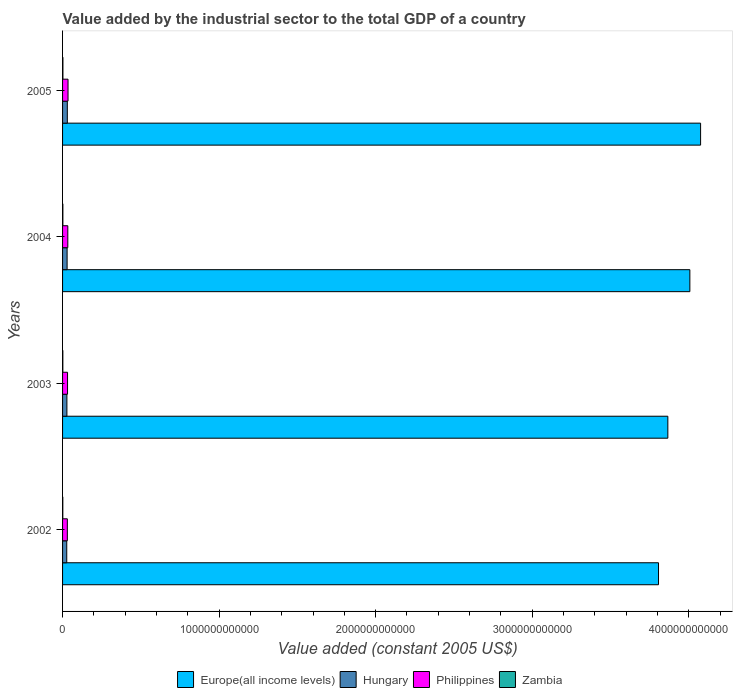How many different coloured bars are there?
Offer a very short reply. 4. Are the number of bars per tick equal to the number of legend labels?
Offer a terse response. Yes. How many bars are there on the 2nd tick from the top?
Offer a terse response. 4. How many bars are there on the 2nd tick from the bottom?
Provide a succinct answer. 4. What is the label of the 4th group of bars from the top?
Ensure brevity in your answer.  2002. In how many cases, is the number of bars for a given year not equal to the number of legend labels?
Ensure brevity in your answer.  0. What is the value added by the industrial sector in Europe(all income levels) in 2002?
Offer a very short reply. 3.81e+12. Across all years, what is the maximum value added by the industrial sector in Europe(all income levels)?
Provide a short and direct response. 4.08e+12. Across all years, what is the minimum value added by the industrial sector in Europe(all income levels)?
Provide a short and direct response. 3.81e+12. What is the total value added by the industrial sector in Zambia in the graph?
Your response must be concise. 7.59e+09. What is the difference between the value added by the industrial sector in Zambia in 2004 and that in 2005?
Offer a terse response. -2.41e+08. What is the difference between the value added by the industrial sector in Europe(all income levels) in 2003 and the value added by the industrial sector in Zambia in 2002?
Make the answer very short. 3.86e+12. What is the average value added by the industrial sector in Europe(all income levels) per year?
Offer a terse response. 3.94e+12. In the year 2005, what is the difference between the value added by the industrial sector in Philippines and value added by the industrial sector in Hungary?
Offer a terse response. 4.41e+09. In how many years, is the value added by the industrial sector in Zambia greater than 3400000000000 US$?
Provide a succinct answer. 0. What is the ratio of the value added by the industrial sector in Hungary in 2002 to that in 2003?
Ensure brevity in your answer.  0.96. Is the difference between the value added by the industrial sector in Philippines in 2002 and 2004 greater than the difference between the value added by the industrial sector in Hungary in 2002 and 2004?
Give a very brief answer. No. What is the difference between the highest and the second highest value added by the industrial sector in Philippines?
Your answer should be compact. 1.40e+09. What is the difference between the highest and the lowest value added by the industrial sector in Philippines?
Provide a short and direct response. 4.37e+09. What does the 3rd bar from the bottom in 2003 represents?
Provide a succinct answer. Philippines. How many bars are there?
Keep it short and to the point. 16. Are all the bars in the graph horizontal?
Your answer should be very brief. Yes. What is the difference between two consecutive major ticks on the X-axis?
Give a very brief answer. 1.00e+12. Are the values on the major ticks of X-axis written in scientific E-notation?
Your response must be concise. No. Does the graph contain any zero values?
Give a very brief answer. No. How many legend labels are there?
Give a very brief answer. 4. How are the legend labels stacked?
Offer a very short reply. Horizontal. What is the title of the graph?
Your response must be concise. Value added by the industrial sector to the total GDP of a country. What is the label or title of the X-axis?
Offer a very short reply. Value added (constant 2005 US$). What is the label or title of the Y-axis?
Provide a succinct answer. Years. What is the Value added (constant 2005 US$) in Europe(all income levels) in 2002?
Provide a short and direct response. 3.81e+12. What is the Value added (constant 2005 US$) in Hungary in 2002?
Your response must be concise. 2.67e+1. What is the Value added (constant 2005 US$) of Philippines in 2002?
Keep it short and to the point. 3.05e+1. What is the Value added (constant 2005 US$) in Zambia in 2002?
Offer a terse response. 1.59e+09. What is the Value added (constant 2005 US$) of Europe(all income levels) in 2003?
Ensure brevity in your answer.  3.87e+12. What is the Value added (constant 2005 US$) in Hungary in 2003?
Provide a succinct answer. 2.77e+1. What is the Value added (constant 2005 US$) of Philippines in 2003?
Keep it short and to the point. 3.18e+1. What is the Value added (constant 2005 US$) of Zambia in 2003?
Offer a terse response. 1.77e+09. What is the Value added (constant 2005 US$) in Europe(all income levels) in 2004?
Make the answer very short. 4.01e+12. What is the Value added (constant 2005 US$) of Hungary in 2004?
Provide a succinct answer. 2.90e+1. What is the Value added (constant 2005 US$) of Philippines in 2004?
Your response must be concise. 3.35e+1. What is the Value added (constant 2005 US$) of Zambia in 2004?
Make the answer very short. 2.00e+09. What is the Value added (constant 2005 US$) of Europe(all income levels) in 2005?
Your answer should be compact. 4.08e+12. What is the Value added (constant 2005 US$) in Hungary in 2005?
Ensure brevity in your answer.  3.05e+1. What is the Value added (constant 2005 US$) of Philippines in 2005?
Give a very brief answer. 3.49e+1. What is the Value added (constant 2005 US$) of Zambia in 2005?
Provide a short and direct response. 2.24e+09. Across all years, what is the maximum Value added (constant 2005 US$) in Europe(all income levels)?
Give a very brief answer. 4.08e+12. Across all years, what is the maximum Value added (constant 2005 US$) of Hungary?
Your answer should be compact. 3.05e+1. Across all years, what is the maximum Value added (constant 2005 US$) in Philippines?
Your response must be concise. 3.49e+1. Across all years, what is the maximum Value added (constant 2005 US$) in Zambia?
Your answer should be compact. 2.24e+09. Across all years, what is the minimum Value added (constant 2005 US$) of Europe(all income levels)?
Offer a very short reply. 3.81e+12. Across all years, what is the minimum Value added (constant 2005 US$) of Hungary?
Provide a short and direct response. 2.67e+1. Across all years, what is the minimum Value added (constant 2005 US$) in Philippines?
Give a very brief answer. 3.05e+1. Across all years, what is the minimum Value added (constant 2005 US$) of Zambia?
Offer a terse response. 1.59e+09. What is the total Value added (constant 2005 US$) of Europe(all income levels) in the graph?
Your answer should be compact. 1.58e+13. What is the total Value added (constant 2005 US$) of Hungary in the graph?
Your answer should be very brief. 1.14e+11. What is the total Value added (constant 2005 US$) in Philippines in the graph?
Offer a very short reply. 1.31e+11. What is the total Value added (constant 2005 US$) of Zambia in the graph?
Give a very brief answer. 7.59e+09. What is the difference between the Value added (constant 2005 US$) of Europe(all income levels) in 2002 and that in 2003?
Give a very brief answer. -5.97e+1. What is the difference between the Value added (constant 2005 US$) of Hungary in 2002 and that in 2003?
Ensure brevity in your answer.  -1.04e+09. What is the difference between the Value added (constant 2005 US$) in Philippines in 2002 and that in 2003?
Offer a very short reply. -1.30e+09. What is the difference between the Value added (constant 2005 US$) of Zambia in 2002 and that in 2003?
Your answer should be very brief. -1.83e+08. What is the difference between the Value added (constant 2005 US$) in Europe(all income levels) in 2002 and that in 2004?
Provide a succinct answer. -2.00e+11. What is the difference between the Value added (constant 2005 US$) of Hungary in 2002 and that in 2004?
Provide a short and direct response. -2.31e+09. What is the difference between the Value added (constant 2005 US$) in Philippines in 2002 and that in 2004?
Offer a terse response. -2.97e+09. What is the difference between the Value added (constant 2005 US$) in Zambia in 2002 and that in 2004?
Your answer should be very brief. -4.07e+08. What is the difference between the Value added (constant 2005 US$) in Europe(all income levels) in 2002 and that in 2005?
Offer a very short reply. -2.69e+11. What is the difference between the Value added (constant 2005 US$) of Hungary in 2002 and that in 2005?
Provide a succinct answer. -3.78e+09. What is the difference between the Value added (constant 2005 US$) of Philippines in 2002 and that in 2005?
Your answer should be compact. -4.37e+09. What is the difference between the Value added (constant 2005 US$) of Zambia in 2002 and that in 2005?
Make the answer very short. -6.48e+08. What is the difference between the Value added (constant 2005 US$) in Europe(all income levels) in 2003 and that in 2004?
Provide a short and direct response. -1.41e+11. What is the difference between the Value added (constant 2005 US$) in Hungary in 2003 and that in 2004?
Provide a short and direct response. -1.28e+09. What is the difference between the Value added (constant 2005 US$) of Philippines in 2003 and that in 2004?
Give a very brief answer. -1.66e+09. What is the difference between the Value added (constant 2005 US$) in Zambia in 2003 and that in 2004?
Your response must be concise. -2.24e+08. What is the difference between the Value added (constant 2005 US$) in Europe(all income levels) in 2003 and that in 2005?
Ensure brevity in your answer.  -2.09e+11. What is the difference between the Value added (constant 2005 US$) of Hungary in 2003 and that in 2005?
Give a very brief answer. -2.74e+09. What is the difference between the Value added (constant 2005 US$) in Philippines in 2003 and that in 2005?
Give a very brief answer. -3.07e+09. What is the difference between the Value added (constant 2005 US$) in Zambia in 2003 and that in 2005?
Offer a terse response. -4.65e+08. What is the difference between the Value added (constant 2005 US$) of Europe(all income levels) in 2004 and that in 2005?
Your response must be concise. -6.85e+1. What is the difference between the Value added (constant 2005 US$) in Hungary in 2004 and that in 2005?
Provide a succinct answer. -1.46e+09. What is the difference between the Value added (constant 2005 US$) in Philippines in 2004 and that in 2005?
Offer a very short reply. -1.40e+09. What is the difference between the Value added (constant 2005 US$) in Zambia in 2004 and that in 2005?
Offer a terse response. -2.41e+08. What is the difference between the Value added (constant 2005 US$) of Europe(all income levels) in 2002 and the Value added (constant 2005 US$) of Hungary in 2003?
Make the answer very short. 3.78e+12. What is the difference between the Value added (constant 2005 US$) of Europe(all income levels) in 2002 and the Value added (constant 2005 US$) of Philippines in 2003?
Offer a very short reply. 3.77e+12. What is the difference between the Value added (constant 2005 US$) of Europe(all income levels) in 2002 and the Value added (constant 2005 US$) of Zambia in 2003?
Offer a very short reply. 3.80e+12. What is the difference between the Value added (constant 2005 US$) in Hungary in 2002 and the Value added (constant 2005 US$) in Philippines in 2003?
Your answer should be compact. -5.12e+09. What is the difference between the Value added (constant 2005 US$) in Hungary in 2002 and the Value added (constant 2005 US$) in Zambia in 2003?
Your response must be concise. 2.49e+1. What is the difference between the Value added (constant 2005 US$) of Philippines in 2002 and the Value added (constant 2005 US$) of Zambia in 2003?
Your response must be concise. 2.87e+1. What is the difference between the Value added (constant 2005 US$) in Europe(all income levels) in 2002 and the Value added (constant 2005 US$) in Hungary in 2004?
Give a very brief answer. 3.78e+12. What is the difference between the Value added (constant 2005 US$) in Europe(all income levels) in 2002 and the Value added (constant 2005 US$) in Philippines in 2004?
Give a very brief answer. 3.77e+12. What is the difference between the Value added (constant 2005 US$) in Europe(all income levels) in 2002 and the Value added (constant 2005 US$) in Zambia in 2004?
Your answer should be compact. 3.80e+12. What is the difference between the Value added (constant 2005 US$) of Hungary in 2002 and the Value added (constant 2005 US$) of Philippines in 2004?
Offer a very short reply. -6.78e+09. What is the difference between the Value added (constant 2005 US$) in Hungary in 2002 and the Value added (constant 2005 US$) in Zambia in 2004?
Your response must be concise. 2.47e+1. What is the difference between the Value added (constant 2005 US$) of Philippines in 2002 and the Value added (constant 2005 US$) of Zambia in 2004?
Your response must be concise. 2.85e+1. What is the difference between the Value added (constant 2005 US$) in Europe(all income levels) in 2002 and the Value added (constant 2005 US$) in Hungary in 2005?
Your response must be concise. 3.78e+12. What is the difference between the Value added (constant 2005 US$) in Europe(all income levels) in 2002 and the Value added (constant 2005 US$) in Philippines in 2005?
Offer a very short reply. 3.77e+12. What is the difference between the Value added (constant 2005 US$) in Europe(all income levels) in 2002 and the Value added (constant 2005 US$) in Zambia in 2005?
Keep it short and to the point. 3.80e+12. What is the difference between the Value added (constant 2005 US$) in Hungary in 2002 and the Value added (constant 2005 US$) in Philippines in 2005?
Give a very brief answer. -8.19e+09. What is the difference between the Value added (constant 2005 US$) in Hungary in 2002 and the Value added (constant 2005 US$) in Zambia in 2005?
Your answer should be very brief. 2.44e+1. What is the difference between the Value added (constant 2005 US$) in Philippines in 2002 and the Value added (constant 2005 US$) in Zambia in 2005?
Your response must be concise. 2.83e+1. What is the difference between the Value added (constant 2005 US$) in Europe(all income levels) in 2003 and the Value added (constant 2005 US$) in Hungary in 2004?
Make the answer very short. 3.84e+12. What is the difference between the Value added (constant 2005 US$) in Europe(all income levels) in 2003 and the Value added (constant 2005 US$) in Philippines in 2004?
Your answer should be very brief. 3.83e+12. What is the difference between the Value added (constant 2005 US$) in Europe(all income levels) in 2003 and the Value added (constant 2005 US$) in Zambia in 2004?
Offer a terse response. 3.86e+12. What is the difference between the Value added (constant 2005 US$) of Hungary in 2003 and the Value added (constant 2005 US$) of Philippines in 2004?
Offer a terse response. -5.75e+09. What is the difference between the Value added (constant 2005 US$) in Hungary in 2003 and the Value added (constant 2005 US$) in Zambia in 2004?
Your response must be concise. 2.57e+1. What is the difference between the Value added (constant 2005 US$) of Philippines in 2003 and the Value added (constant 2005 US$) of Zambia in 2004?
Give a very brief answer. 2.98e+1. What is the difference between the Value added (constant 2005 US$) in Europe(all income levels) in 2003 and the Value added (constant 2005 US$) in Hungary in 2005?
Give a very brief answer. 3.84e+12. What is the difference between the Value added (constant 2005 US$) of Europe(all income levels) in 2003 and the Value added (constant 2005 US$) of Philippines in 2005?
Provide a succinct answer. 3.83e+12. What is the difference between the Value added (constant 2005 US$) of Europe(all income levels) in 2003 and the Value added (constant 2005 US$) of Zambia in 2005?
Keep it short and to the point. 3.86e+12. What is the difference between the Value added (constant 2005 US$) in Hungary in 2003 and the Value added (constant 2005 US$) in Philippines in 2005?
Provide a short and direct response. -7.15e+09. What is the difference between the Value added (constant 2005 US$) of Hungary in 2003 and the Value added (constant 2005 US$) of Zambia in 2005?
Offer a terse response. 2.55e+1. What is the difference between the Value added (constant 2005 US$) in Philippines in 2003 and the Value added (constant 2005 US$) in Zambia in 2005?
Provide a short and direct response. 2.96e+1. What is the difference between the Value added (constant 2005 US$) of Europe(all income levels) in 2004 and the Value added (constant 2005 US$) of Hungary in 2005?
Your answer should be very brief. 3.98e+12. What is the difference between the Value added (constant 2005 US$) of Europe(all income levels) in 2004 and the Value added (constant 2005 US$) of Philippines in 2005?
Provide a short and direct response. 3.97e+12. What is the difference between the Value added (constant 2005 US$) of Europe(all income levels) in 2004 and the Value added (constant 2005 US$) of Zambia in 2005?
Your answer should be compact. 4.00e+12. What is the difference between the Value added (constant 2005 US$) in Hungary in 2004 and the Value added (constant 2005 US$) in Philippines in 2005?
Your answer should be very brief. -5.87e+09. What is the difference between the Value added (constant 2005 US$) of Hungary in 2004 and the Value added (constant 2005 US$) of Zambia in 2005?
Ensure brevity in your answer.  2.68e+1. What is the difference between the Value added (constant 2005 US$) of Philippines in 2004 and the Value added (constant 2005 US$) of Zambia in 2005?
Offer a very short reply. 3.12e+1. What is the average Value added (constant 2005 US$) in Europe(all income levels) per year?
Provide a succinct answer. 3.94e+12. What is the average Value added (constant 2005 US$) of Hungary per year?
Provide a short and direct response. 2.85e+1. What is the average Value added (constant 2005 US$) in Philippines per year?
Give a very brief answer. 3.27e+1. What is the average Value added (constant 2005 US$) in Zambia per year?
Offer a terse response. 1.90e+09. In the year 2002, what is the difference between the Value added (constant 2005 US$) in Europe(all income levels) and Value added (constant 2005 US$) in Hungary?
Your answer should be compact. 3.78e+12. In the year 2002, what is the difference between the Value added (constant 2005 US$) in Europe(all income levels) and Value added (constant 2005 US$) in Philippines?
Keep it short and to the point. 3.78e+12. In the year 2002, what is the difference between the Value added (constant 2005 US$) of Europe(all income levels) and Value added (constant 2005 US$) of Zambia?
Provide a short and direct response. 3.81e+12. In the year 2002, what is the difference between the Value added (constant 2005 US$) in Hungary and Value added (constant 2005 US$) in Philippines?
Your response must be concise. -3.82e+09. In the year 2002, what is the difference between the Value added (constant 2005 US$) in Hungary and Value added (constant 2005 US$) in Zambia?
Your response must be concise. 2.51e+1. In the year 2002, what is the difference between the Value added (constant 2005 US$) in Philippines and Value added (constant 2005 US$) in Zambia?
Provide a short and direct response. 2.89e+1. In the year 2003, what is the difference between the Value added (constant 2005 US$) of Europe(all income levels) and Value added (constant 2005 US$) of Hungary?
Keep it short and to the point. 3.84e+12. In the year 2003, what is the difference between the Value added (constant 2005 US$) of Europe(all income levels) and Value added (constant 2005 US$) of Philippines?
Make the answer very short. 3.83e+12. In the year 2003, what is the difference between the Value added (constant 2005 US$) in Europe(all income levels) and Value added (constant 2005 US$) in Zambia?
Offer a very short reply. 3.86e+12. In the year 2003, what is the difference between the Value added (constant 2005 US$) of Hungary and Value added (constant 2005 US$) of Philippines?
Keep it short and to the point. -4.08e+09. In the year 2003, what is the difference between the Value added (constant 2005 US$) of Hungary and Value added (constant 2005 US$) of Zambia?
Provide a succinct answer. 2.60e+1. In the year 2003, what is the difference between the Value added (constant 2005 US$) in Philippines and Value added (constant 2005 US$) in Zambia?
Offer a very short reply. 3.00e+1. In the year 2004, what is the difference between the Value added (constant 2005 US$) in Europe(all income levels) and Value added (constant 2005 US$) in Hungary?
Offer a terse response. 3.98e+12. In the year 2004, what is the difference between the Value added (constant 2005 US$) in Europe(all income levels) and Value added (constant 2005 US$) in Philippines?
Give a very brief answer. 3.97e+12. In the year 2004, what is the difference between the Value added (constant 2005 US$) in Europe(all income levels) and Value added (constant 2005 US$) in Zambia?
Your answer should be compact. 4.00e+12. In the year 2004, what is the difference between the Value added (constant 2005 US$) of Hungary and Value added (constant 2005 US$) of Philippines?
Your answer should be compact. -4.47e+09. In the year 2004, what is the difference between the Value added (constant 2005 US$) of Hungary and Value added (constant 2005 US$) of Zambia?
Provide a short and direct response. 2.70e+1. In the year 2004, what is the difference between the Value added (constant 2005 US$) of Philippines and Value added (constant 2005 US$) of Zambia?
Give a very brief answer. 3.15e+1. In the year 2005, what is the difference between the Value added (constant 2005 US$) in Europe(all income levels) and Value added (constant 2005 US$) in Hungary?
Provide a short and direct response. 4.04e+12. In the year 2005, what is the difference between the Value added (constant 2005 US$) in Europe(all income levels) and Value added (constant 2005 US$) in Philippines?
Make the answer very short. 4.04e+12. In the year 2005, what is the difference between the Value added (constant 2005 US$) of Europe(all income levels) and Value added (constant 2005 US$) of Zambia?
Offer a terse response. 4.07e+12. In the year 2005, what is the difference between the Value added (constant 2005 US$) of Hungary and Value added (constant 2005 US$) of Philippines?
Provide a short and direct response. -4.41e+09. In the year 2005, what is the difference between the Value added (constant 2005 US$) in Hungary and Value added (constant 2005 US$) in Zambia?
Make the answer very short. 2.82e+1. In the year 2005, what is the difference between the Value added (constant 2005 US$) in Philippines and Value added (constant 2005 US$) in Zambia?
Your answer should be very brief. 3.26e+1. What is the ratio of the Value added (constant 2005 US$) of Europe(all income levels) in 2002 to that in 2003?
Make the answer very short. 0.98. What is the ratio of the Value added (constant 2005 US$) of Hungary in 2002 to that in 2003?
Offer a terse response. 0.96. What is the ratio of the Value added (constant 2005 US$) of Zambia in 2002 to that in 2003?
Give a very brief answer. 0.9. What is the ratio of the Value added (constant 2005 US$) in Hungary in 2002 to that in 2004?
Provide a succinct answer. 0.92. What is the ratio of the Value added (constant 2005 US$) in Philippines in 2002 to that in 2004?
Offer a very short reply. 0.91. What is the ratio of the Value added (constant 2005 US$) of Zambia in 2002 to that in 2004?
Provide a succinct answer. 0.8. What is the ratio of the Value added (constant 2005 US$) in Europe(all income levels) in 2002 to that in 2005?
Give a very brief answer. 0.93. What is the ratio of the Value added (constant 2005 US$) in Hungary in 2002 to that in 2005?
Ensure brevity in your answer.  0.88. What is the ratio of the Value added (constant 2005 US$) of Philippines in 2002 to that in 2005?
Your answer should be compact. 0.87. What is the ratio of the Value added (constant 2005 US$) of Zambia in 2002 to that in 2005?
Offer a terse response. 0.71. What is the ratio of the Value added (constant 2005 US$) of Europe(all income levels) in 2003 to that in 2004?
Your answer should be very brief. 0.96. What is the ratio of the Value added (constant 2005 US$) in Hungary in 2003 to that in 2004?
Make the answer very short. 0.96. What is the ratio of the Value added (constant 2005 US$) in Philippines in 2003 to that in 2004?
Keep it short and to the point. 0.95. What is the ratio of the Value added (constant 2005 US$) of Zambia in 2003 to that in 2004?
Your answer should be very brief. 0.89. What is the ratio of the Value added (constant 2005 US$) of Europe(all income levels) in 2003 to that in 2005?
Your answer should be very brief. 0.95. What is the ratio of the Value added (constant 2005 US$) of Hungary in 2003 to that in 2005?
Offer a very short reply. 0.91. What is the ratio of the Value added (constant 2005 US$) of Philippines in 2003 to that in 2005?
Your answer should be compact. 0.91. What is the ratio of the Value added (constant 2005 US$) of Zambia in 2003 to that in 2005?
Offer a terse response. 0.79. What is the ratio of the Value added (constant 2005 US$) of Europe(all income levels) in 2004 to that in 2005?
Your answer should be compact. 0.98. What is the ratio of the Value added (constant 2005 US$) in Philippines in 2004 to that in 2005?
Provide a short and direct response. 0.96. What is the ratio of the Value added (constant 2005 US$) in Zambia in 2004 to that in 2005?
Your response must be concise. 0.89. What is the difference between the highest and the second highest Value added (constant 2005 US$) in Europe(all income levels)?
Ensure brevity in your answer.  6.85e+1. What is the difference between the highest and the second highest Value added (constant 2005 US$) of Hungary?
Keep it short and to the point. 1.46e+09. What is the difference between the highest and the second highest Value added (constant 2005 US$) in Philippines?
Your answer should be very brief. 1.40e+09. What is the difference between the highest and the second highest Value added (constant 2005 US$) in Zambia?
Your answer should be very brief. 2.41e+08. What is the difference between the highest and the lowest Value added (constant 2005 US$) in Europe(all income levels)?
Offer a terse response. 2.69e+11. What is the difference between the highest and the lowest Value added (constant 2005 US$) of Hungary?
Make the answer very short. 3.78e+09. What is the difference between the highest and the lowest Value added (constant 2005 US$) of Philippines?
Provide a succinct answer. 4.37e+09. What is the difference between the highest and the lowest Value added (constant 2005 US$) in Zambia?
Offer a terse response. 6.48e+08. 